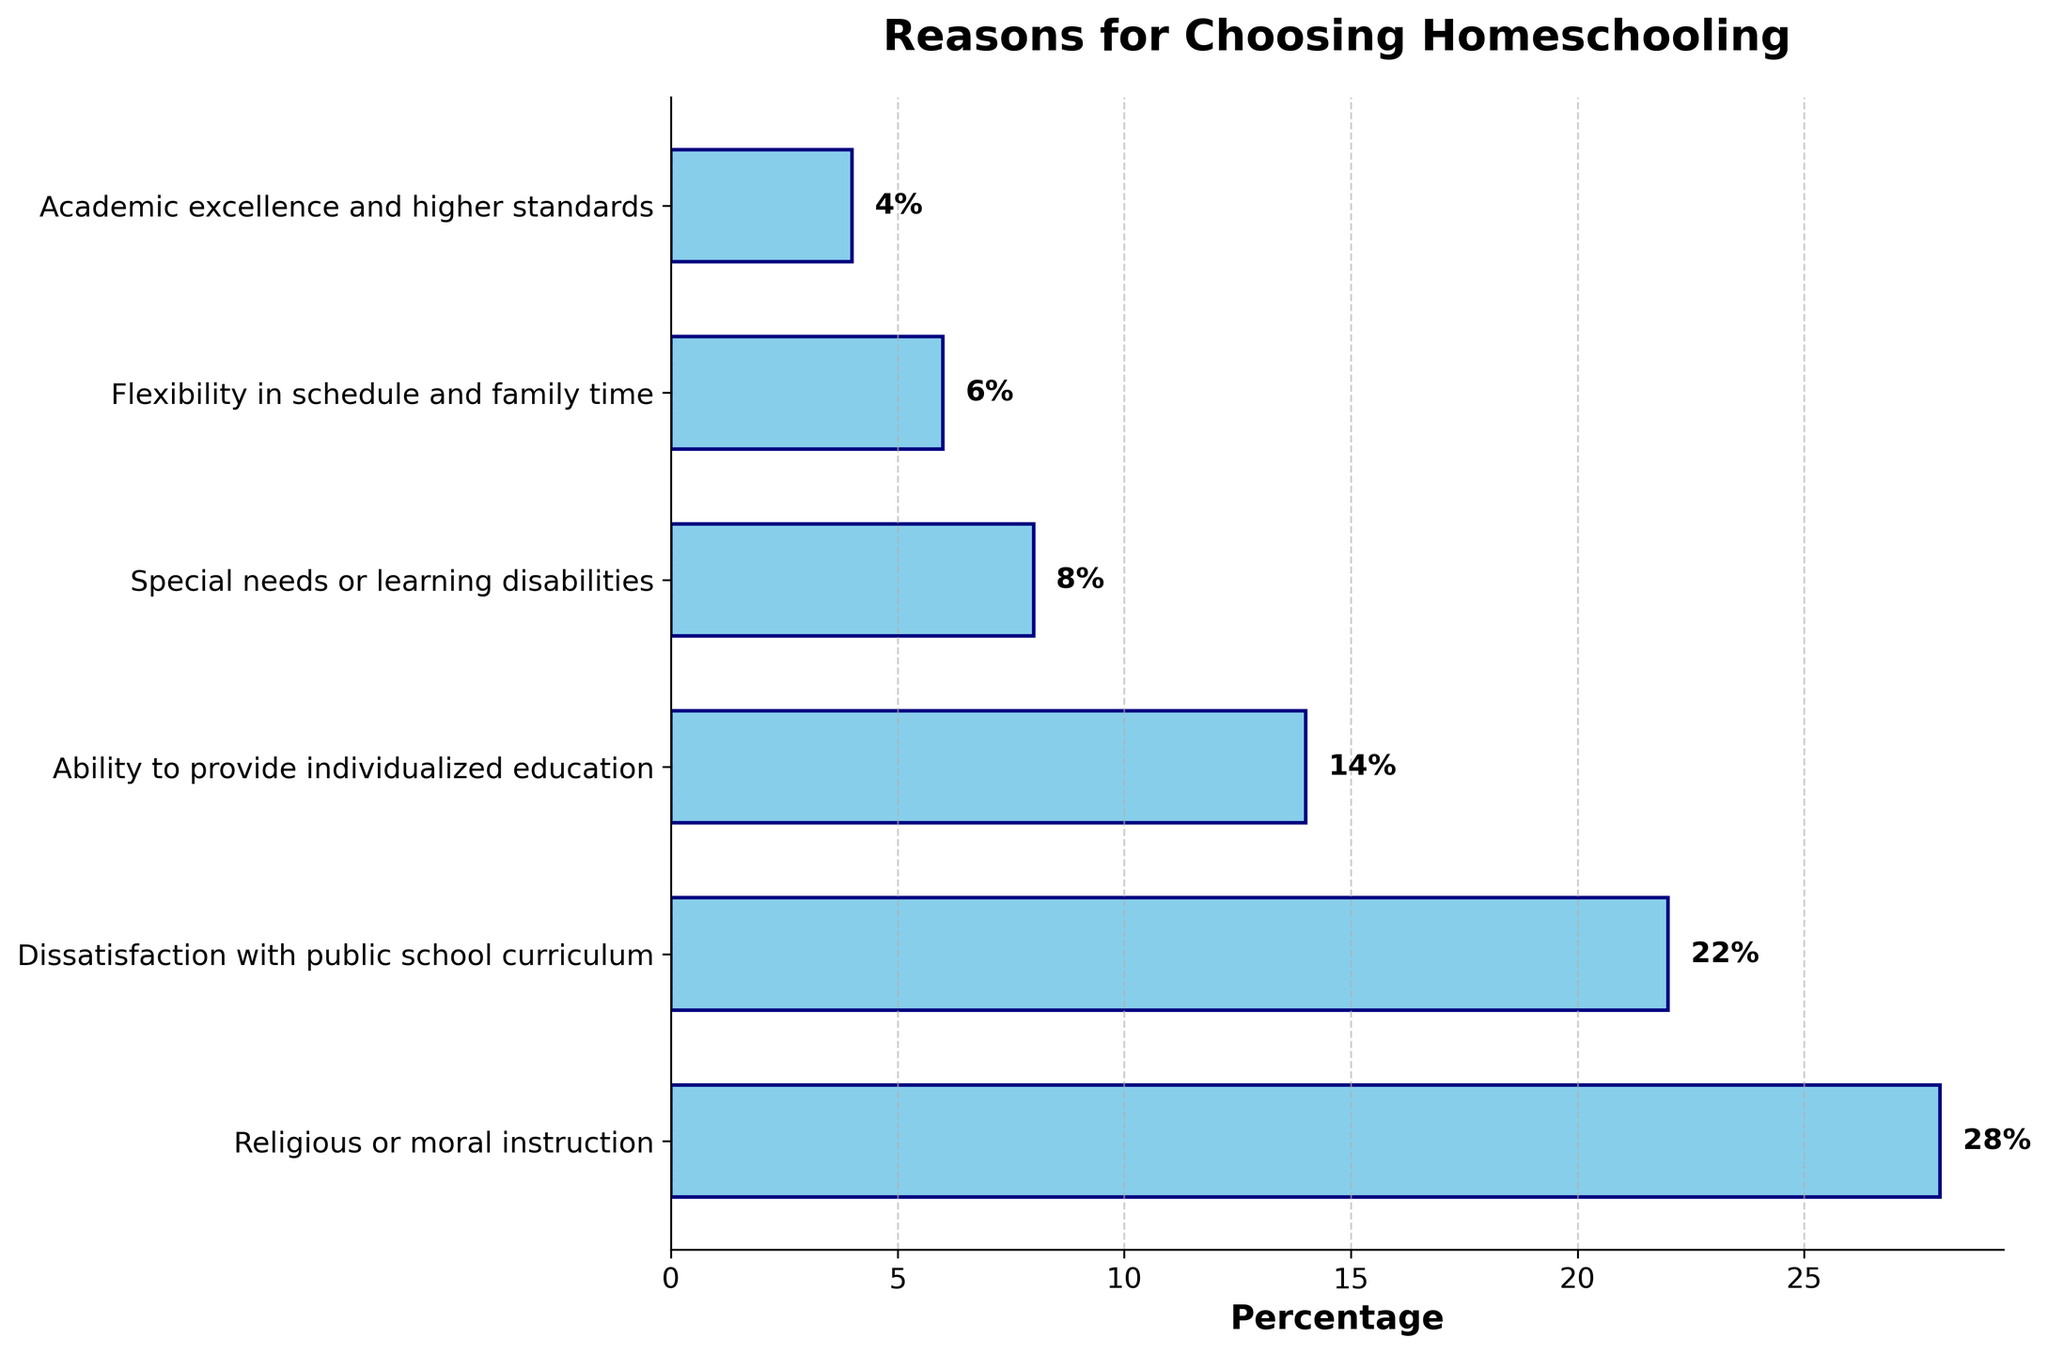What is the most common reason families choose homeschooling? The most common reason can be identified by the bar with the highest percentage value in the chart. The tallest bar corresponds to "Religious or moral instruction" with 28%.
Answer: Religious or moral instruction What is the combined percentage of families choosing homeschooling for special needs or learning disabilities and academic excellence and higher standards? To find the combined percentage, add the percentages of these two reasons. Special needs or learning disabilities account for 8% and academic excellence and higher standards for 4%. 8 + 4 = 12%.
Answer: 12% Which reason has a higher percentage: dissatisfaction with public school curriculum or flexibility in schedule and family time? Compare the bars for these two reasons. Dissatisfaction with public school curriculum has a percentage of 22%, while flexibility in schedule and family time has a percentage of 6%. 22% is greater than 6%.
Answer: Dissatisfaction with public school curriculum Which reason is least common among the families and what is its percentage? The least common reason can be identified by the shortest bar in the chart. The shortest bar corresponds to "Academic excellence and higher standards" with a percentage of 4%.
Answer: Academic excellence and higher standards, 4% How much higher is the percentage of choosing homeschooling for religious or moral instruction compared to individualized education? Subtract the percentage for individualized education from the percentage for religious or moral instruction: 28% - 14% = 14%.
Answer: 14% What is the percentage difference between families who choose homeschooling for academic excellence and those who choose it for flexibility in schedule and family time? Calculate the percentage difference by subtracting one from the other: 6% - 4% = 2%.
Answer: 2% What percentage of families choose homeschooling for reasons related to educational quality (dissatisfaction with curriculum and academic excellence)? Add the percentages for dissatisfaction with public school curriculum and academic excellence and higher standards: 22% + 4% = 26%.
Answer: 26% Is the percentage of families choosing homeschooling for special needs higher or lower than those choosing it for individualized education? Compare the bars for these two reasons. Special needs have a percentage of 8%, whereas individualized education has a percentage of 14%. 8% is lower than 14%.
Answer: Lower 